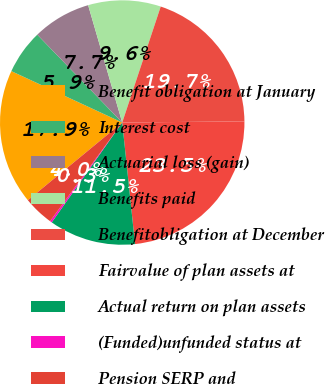Convert chart. <chart><loc_0><loc_0><loc_500><loc_500><pie_chart><fcel>Benefit obligation at January<fcel>Interest cost<fcel>Actuarial loss (gain)<fcel>Benefits paid<fcel>Benefitobligation at December<fcel>Fairvalue of plan assets at<fcel>Actual return on plan assets<fcel>(Funded)unfunded status at<fcel>Pension SERP and<nl><fcel>17.87%<fcel>5.86%<fcel>7.73%<fcel>9.6%<fcel>19.74%<fcel>23.48%<fcel>11.46%<fcel>0.26%<fcel>3.99%<nl></chart> 